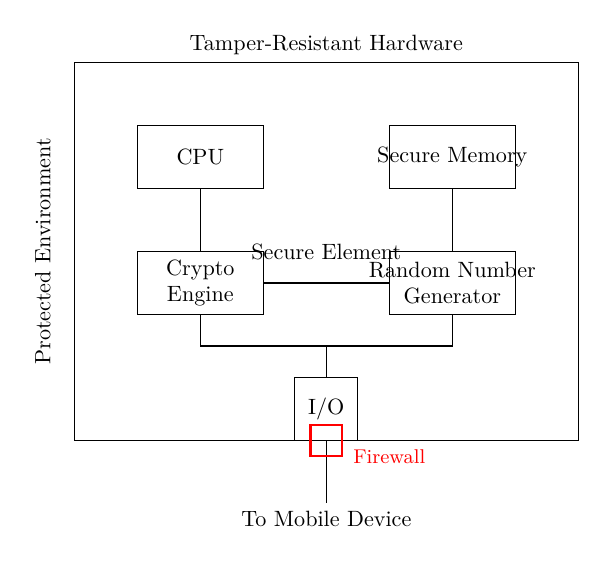What is the primary function of the secure element? The secure element is designed to store cryptographic keys and perform sensitive operations, ensuring security in mobile devices.
Answer: Store cryptographic keys What components are included in the secure element circuit? The circuit includes a CPU, secure memory, crypto engine, random number generator, I/O interface, and a firewall, showing various functionalities.
Answer: CPU, secure memory, crypto engine, random number generator, I/O, firewall What does the firewall represent in this circuit? The firewall represents a security measure to protect the secure element from unauthorized access, preventing external threats.
Answer: Security measure How does the random number generator contribute to security? The random number generator produces unpredictable values essential for cryptographic operations, helping to enhance security by ensuring key randomness.
Answer: Enhances security Why is the circuit classified as tamper-resistant? The circuit is classified as tamper-resistant because it is designed to protect the secure element from physical attacks, preventing unauthorized access to sensitive data.
Answer: Physical attack protection What symbol is used to indicate encryption in the diagram? The encryption symbol used in the circuit is a lock, which visually represents secure data encryption associated with the secure element operations.
Answer: Lock symbol 